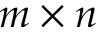<formula> <loc_0><loc_0><loc_500><loc_500>m \times n</formula> 